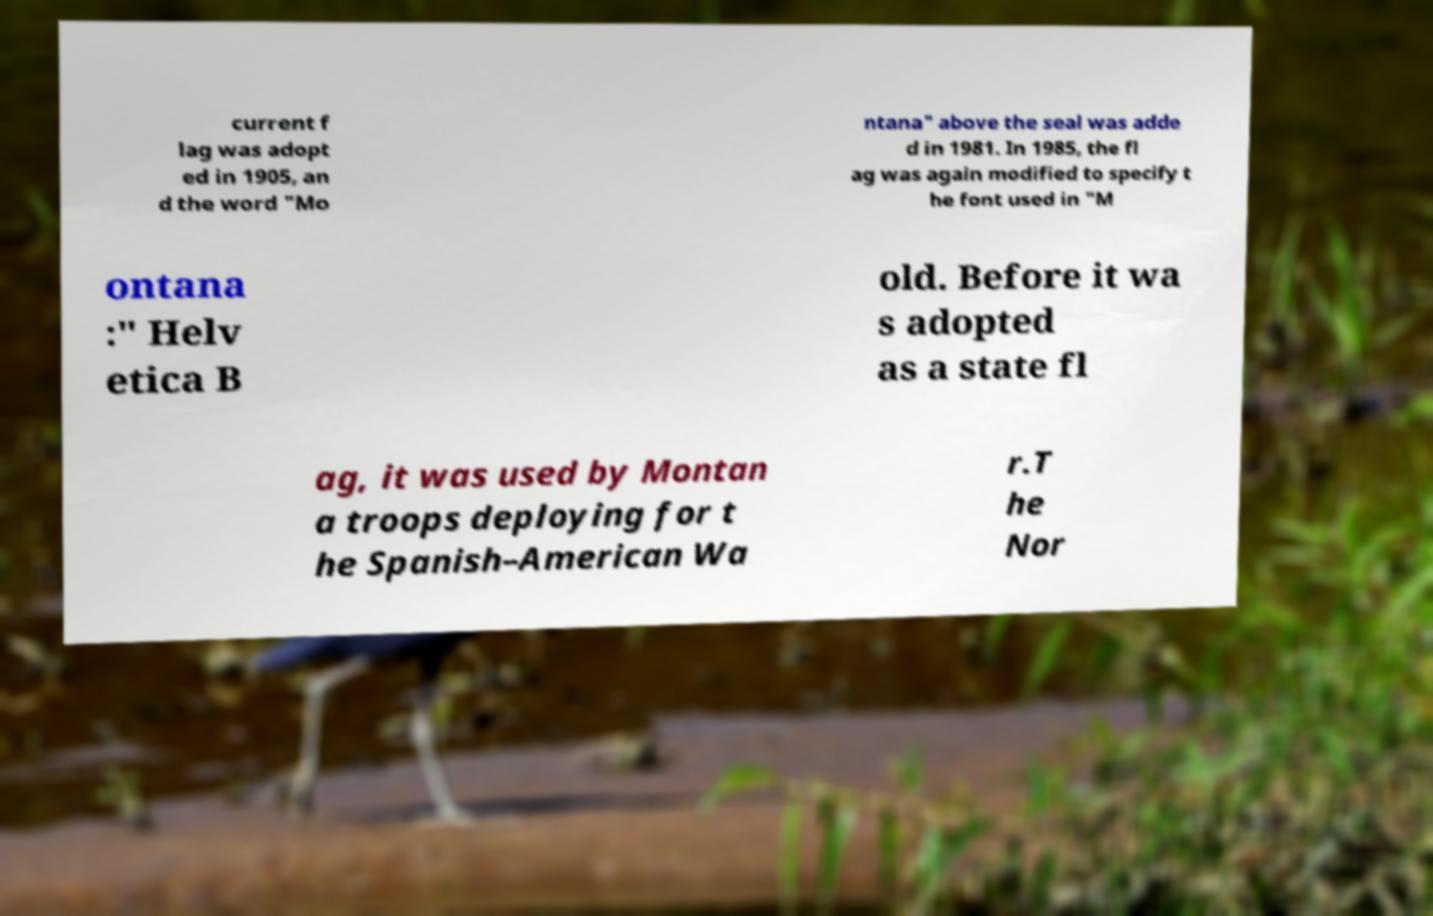Can you accurately transcribe the text from the provided image for me? current f lag was adopt ed in 1905, an d the word "Mo ntana" above the seal was adde d in 1981. In 1985, the fl ag was again modified to specify t he font used in "M ontana :" Helv etica B old. Before it wa s adopted as a state fl ag, it was used by Montan a troops deploying for t he Spanish–American Wa r.T he Nor 